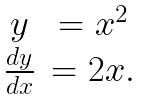Convert formula to latex. <formula><loc_0><loc_0><loc_500><loc_500>\begin{matrix} y & = x ^ { 2 } \\ \frac { d y } { d x } & = 2 x . \end{matrix}</formula> 